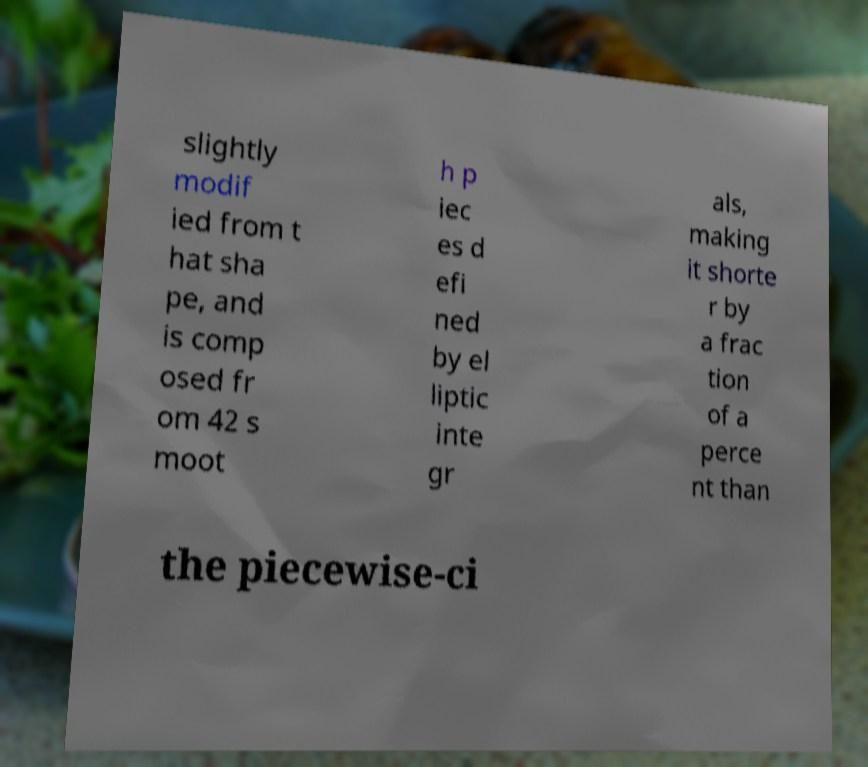Please read and relay the text visible in this image. What does it say? slightly modif ied from t hat sha pe, and is comp osed fr om 42 s moot h p iec es d efi ned by el liptic inte gr als, making it shorte r by a frac tion of a perce nt than the piecewise-ci 